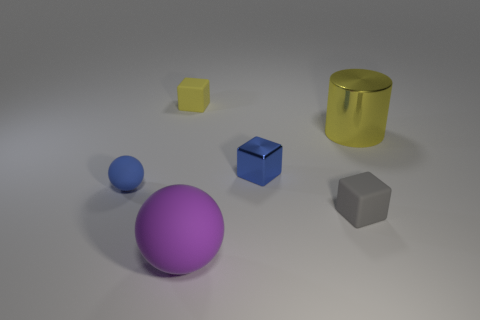There is a gray thing that is the same material as the big purple ball; what is its size?
Your response must be concise. Small. Is the material of the tiny blue block the same as the tiny yellow block?
Make the answer very short. No. What color is the rubber cube behind the tiny blue matte sphere in front of the metal object to the left of the large yellow cylinder?
Your answer should be compact. Yellow. The yellow metal thing has what shape?
Provide a short and direct response. Cylinder. There is a big shiny cylinder; is it the same color as the small matte object that is behind the large shiny thing?
Offer a very short reply. Yes. Are there the same number of blue rubber spheres in front of the purple ball and things?
Offer a very short reply. No. How many blue matte balls have the same size as the metallic cylinder?
Offer a very short reply. 0. There is a thing that is the same color as the metal block; what shape is it?
Offer a terse response. Sphere. Are any cylinders visible?
Offer a very short reply. Yes. Do the large object that is in front of the small gray cube and the shiny thing to the left of the large yellow cylinder have the same shape?
Ensure brevity in your answer.  No. 